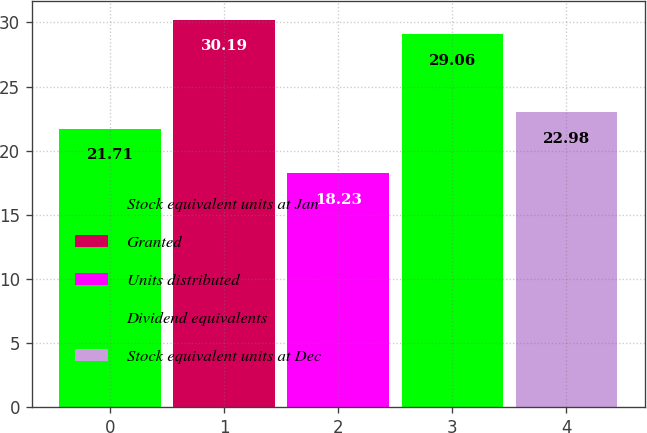Convert chart. <chart><loc_0><loc_0><loc_500><loc_500><bar_chart><fcel>Stock equivalent units at Jan<fcel>Granted<fcel>Units distributed<fcel>Dividend equivalents<fcel>Stock equivalent units at Dec<nl><fcel>21.71<fcel>30.19<fcel>18.23<fcel>29.06<fcel>22.98<nl></chart> 